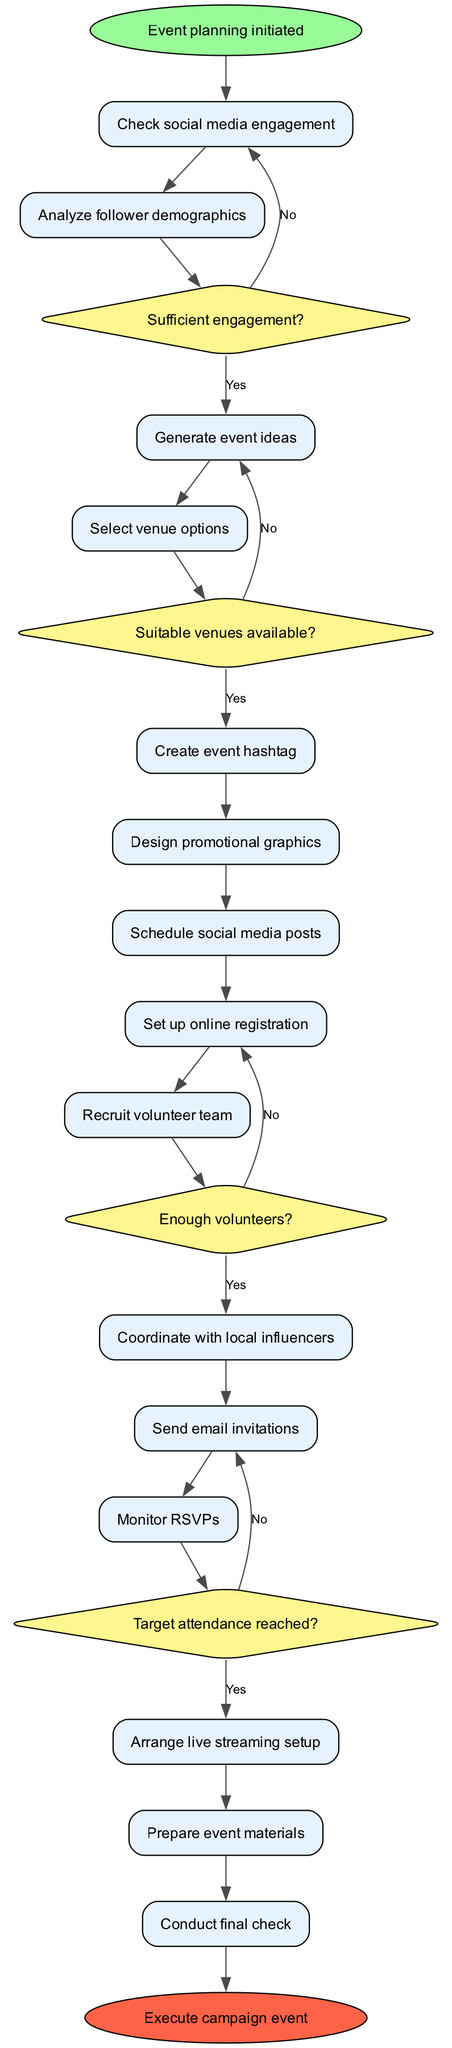What is the starting point of this flowchart? The flowchart begins with the node labeled "Event planning initiated," which serves as the starting point before any actions are taken.
Answer: Event planning initiated How many decision nodes are present in the diagram? There are four decision nodes in the flowchart representing points where a choice must be made regarding engagement, venue availability, volunteer status, and target attendance.
Answer: 4 Which node comes after "Send email invitations"? The node that follows "Send email invitations" is "Monitor RSVPs," which is where the responses from the invitations are tracked.
Answer: Monitor RSVPs What happens if there are not enough volunteers according to the flowchart? If there are not enough volunteers, as indicated by the decision connected to "Enough volunteers?", the flow returns to the "Set up online registration" node to possibly seek more volunteers.
Answer: Go back to Set up online registration What is the end point of the flowchart? The endpoint of the flowchart is labeled "Execute campaign event," which signifies that all necessary preparations have been completed, and the event can take place.
Answer: Execute campaign event What node follows "Check social media engagement"? The node that follows "Check social media engagement" is "Analyze follower demographics," which indicates the next step in the process after assessing engagement metrics.
Answer: Analyze follower demographics What happens if the target attendance is not reached? If the target attendance is not reached, the next action is to return to "Send email invitations," implying that further outreach will be necessary to meet attendance goals.
Answer: Return to Send email invitations Which node is associated with designing materials for the event? "Design promotional graphics" is the node that focuses on creating visual materials that will be used to promote the campaign event.
Answer: Design promotional graphics 